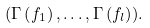Convert formula to latex. <formula><loc_0><loc_0><loc_500><loc_500>( \Gamma \left ( f _ { 1 } \right ) , \dots , \Gamma \left ( f _ { l } \right ) ) .</formula> 